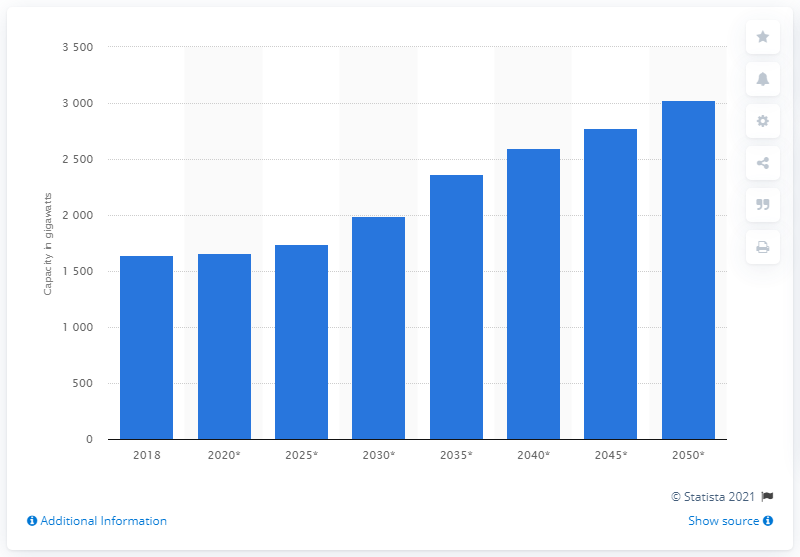List a handful of essential elements in this visual. The forecasted installed power generation capacity of natural gas worldwide was in 2018. 